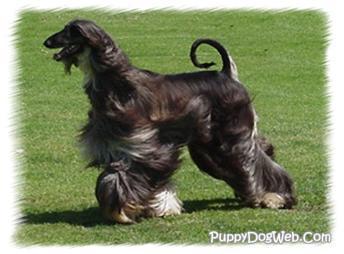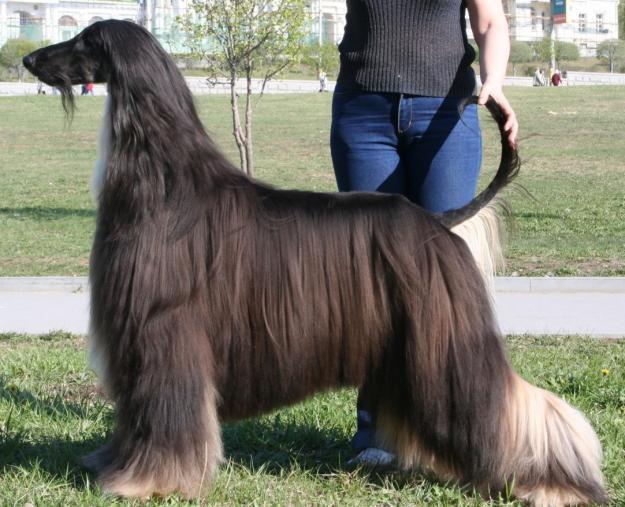The first image is the image on the left, the second image is the image on the right. Assess this claim about the two images: "A person in white slacks and a blazer stands directly behind a posed long-haired hound.". Correct or not? Answer yes or no. No. The first image is the image on the left, the second image is the image on the right. Given the left and right images, does the statement "There are only two dogs, and they are facing in opposite directions of each other." hold true? Answer yes or no. No. 